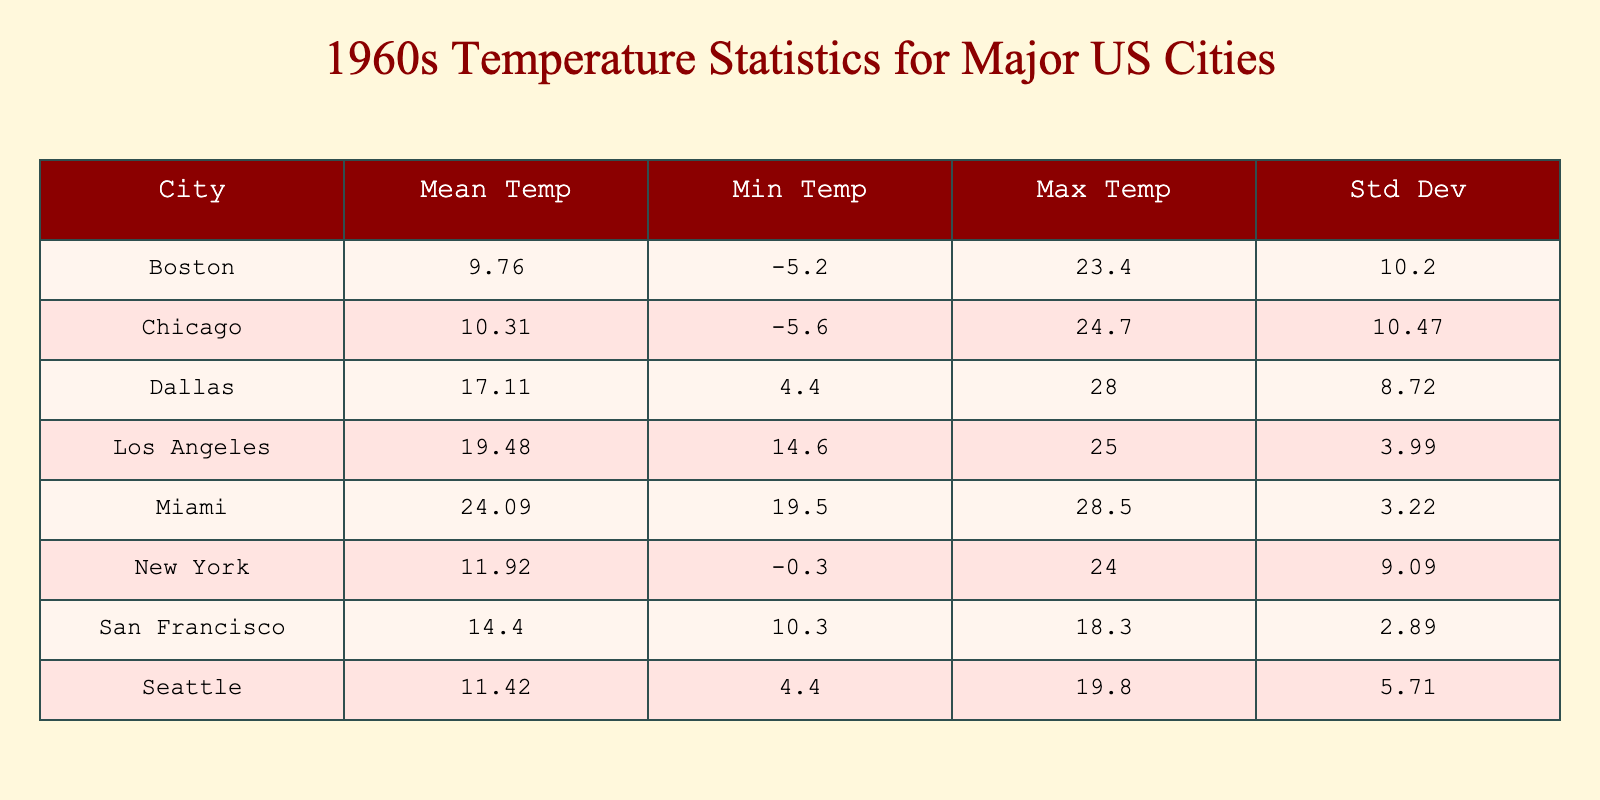What is the mean temperature for Los Angeles in 1960? The mean temperature for Los Angeles is found in the "Mean Temp" column for that city. Looking at the table, it states that the mean temperature for Los Angeles is 20.16 degrees Celsius.
Answer: 20.16 Which city had the highest minimum temperature in 1960? The minimum temperatures for each city are listed in the "Min Temp" column. I compare the minimum values, and it shows that Miami has the highest minimum temperature at 19.5 degrees Celsius.
Answer: Miami What is the difference between the maximum temperature of Miami and that of Chicago in 1960? The maximum temperature for Miami is 28.5 degrees Celsius, and for Chicago, it is 24.7 degrees Celsius. The difference is calculated by subtracting Chicago’s maximum from Miami’s maximum: 28.5 - 24.7 = 3.8 degrees Celsius.
Answer: 3.8 Is the average temperature for New York greater than that for Boston in 1960? The average temperature for New York is 12.91 degrees Celsius, while Boston has an average of 9.96 degrees Celsius. Since 12.91 is greater than 9.96, the statement is true.
Answer: Yes What is the standard deviation of temperatures for Seattle in 1960? The "Std Dev" column shows the standard deviation of temperatures for each city. For Seattle, the standard deviation is calculated to be 5.07 degrees Celsius.
Answer: 5.07 How does the average temperature in July compare between Los Angeles and New York? The average temperature for Los Angeles in July is listed under "July" and is 24.5 degrees Celsius, while New York's July average is 24.0 degrees Celsius. Comparing these, Los Angeles is warmer in July by 0.5 degrees.
Answer: Los Angeles is warmer by 0.5 degrees Which city had the lowest average temperature overall in 1960? By looking at the "Mean Temp" column for all cities, I can see that Chicago has the lowest average temperature of 10.42 degrees Celsius, making it the city with the lowest overall average temperature.
Answer: Chicago Did any city have a month with temperatures below zero degrees Celsius? The "Min Temp" column lists the lowest temperatures for each city. Upon examining the data, I find that New York, Chicago, and Boston all show minimum temperatures below zero, indicating this statement is true.
Answer: Yes What is the average temperature for Dallas in the summer months (June to August) of 1960? The summer months are June (25.0), July (28.0), and August (27.5). I calculate the average by summing these values (25.0 + 28.0 + 27.5) = 80.5 degrees and then dividing by 3. The average temperature for Dallas in summer is approximately 26.83 degrees Celsius.
Answer: 26.83 